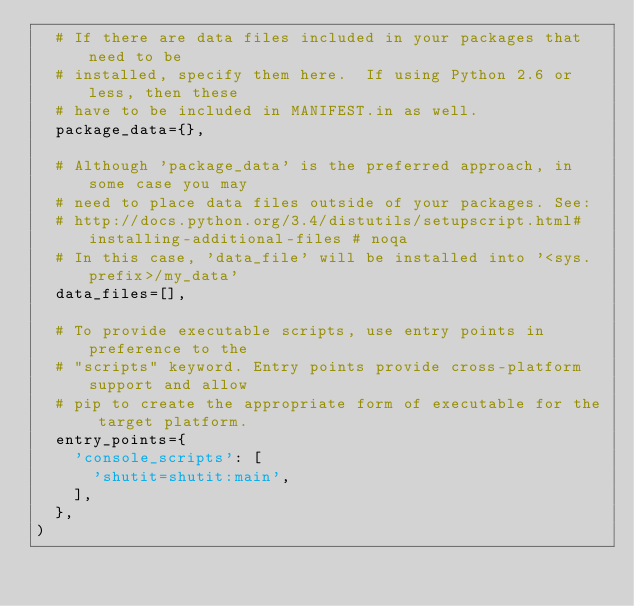<code> <loc_0><loc_0><loc_500><loc_500><_Python_>	# If there are data files included in your packages that need to be
	# installed, specify them here.  If using Python 2.6 or less, then these
	# have to be included in MANIFEST.in as well.
	package_data={},

	# Although 'package_data' is the preferred approach, in some case you may
	# need to place data files outside of your packages. See:
	# http://docs.python.org/3.4/distutils/setupscript.html#installing-additional-files # noqa
	# In this case, 'data_file' will be installed into '<sys.prefix>/my_data'
	data_files=[],

	# To provide executable scripts, use entry points in preference to the
	# "scripts" keyword. Entry points provide cross-platform support and allow
	# pip to create the appropriate form of executable for the target platform.
	entry_points={
		'console_scripts': [
			'shutit=shutit:main',
		],
	},
)
</code> 